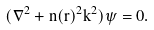<formula> <loc_0><loc_0><loc_500><loc_500>( \nabla ^ { 2 } + n ( { r } ) ^ { 2 } k ^ { 2 } ) \psi = 0 .</formula> 